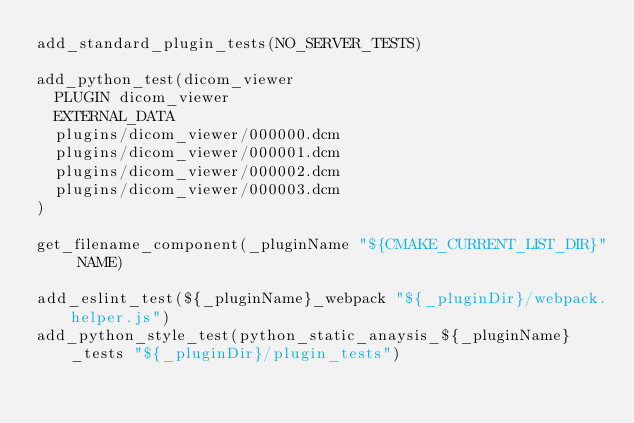<code> <loc_0><loc_0><loc_500><loc_500><_CMake_>add_standard_plugin_tests(NO_SERVER_TESTS)

add_python_test(dicom_viewer
  PLUGIN dicom_viewer
  EXTERNAL_DATA
  plugins/dicom_viewer/000000.dcm
  plugins/dicom_viewer/000001.dcm
  plugins/dicom_viewer/000002.dcm
  plugins/dicom_viewer/000003.dcm
)

get_filename_component(_pluginName "${CMAKE_CURRENT_LIST_DIR}" NAME)

add_eslint_test(${_pluginName}_webpack "${_pluginDir}/webpack.helper.js")
add_python_style_test(python_static_anaysis_${_pluginName}_tests "${_pluginDir}/plugin_tests")
</code> 